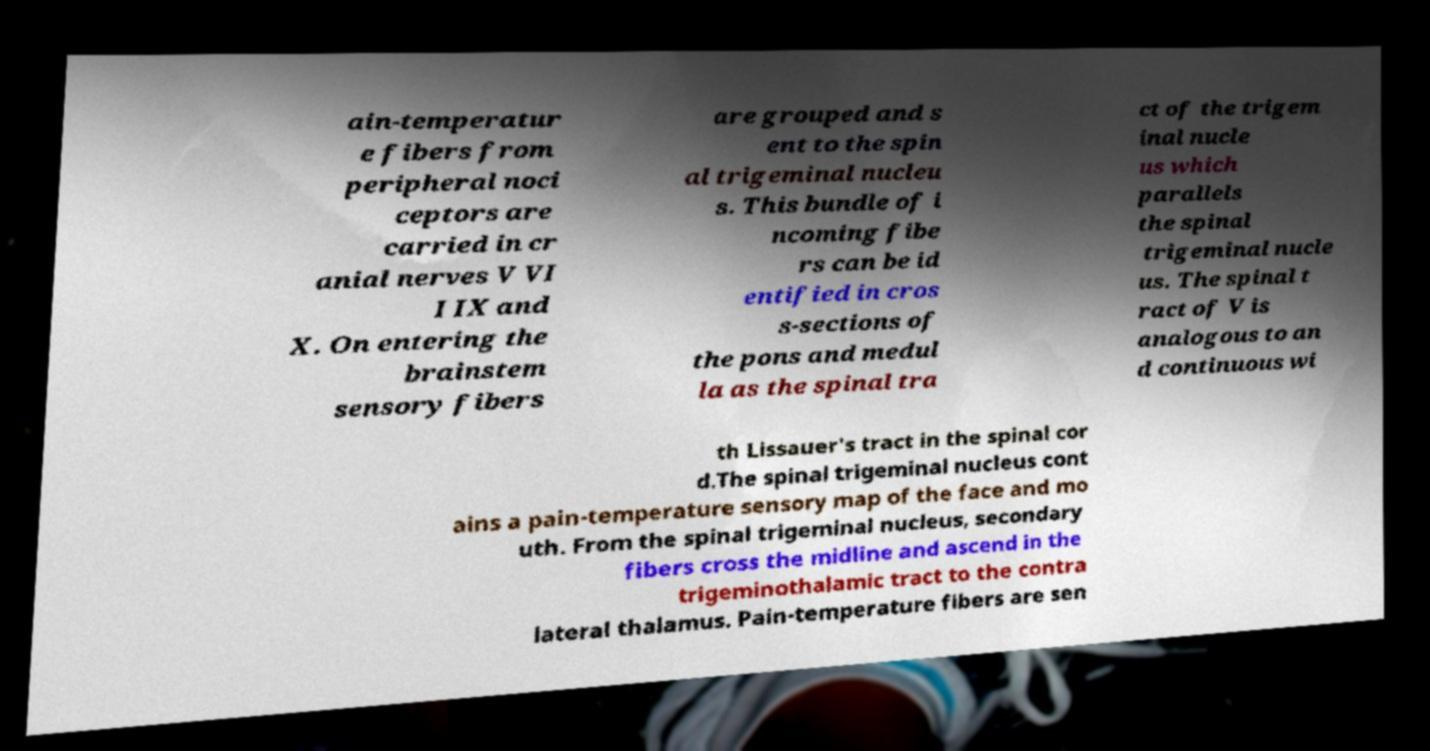There's text embedded in this image that I need extracted. Can you transcribe it verbatim? ain-temperatur e fibers from peripheral noci ceptors are carried in cr anial nerves V VI I IX and X. On entering the brainstem sensory fibers are grouped and s ent to the spin al trigeminal nucleu s. This bundle of i ncoming fibe rs can be id entified in cros s-sections of the pons and medul la as the spinal tra ct of the trigem inal nucle us which parallels the spinal trigeminal nucle us. The spinal t ract of V is analogous to an d continuous wi th Lissauer's tract in the spinal cor d.The spinal trigeminal nucleus cont ains a pain-temperature sensory map of the face and mo uth. From the spinal trigeminal nucleus, secondary fibers cross the midline and ascend in the trigeminothalamic tract to the contra lateral thalamus. Pain-temperature fibers are sen 